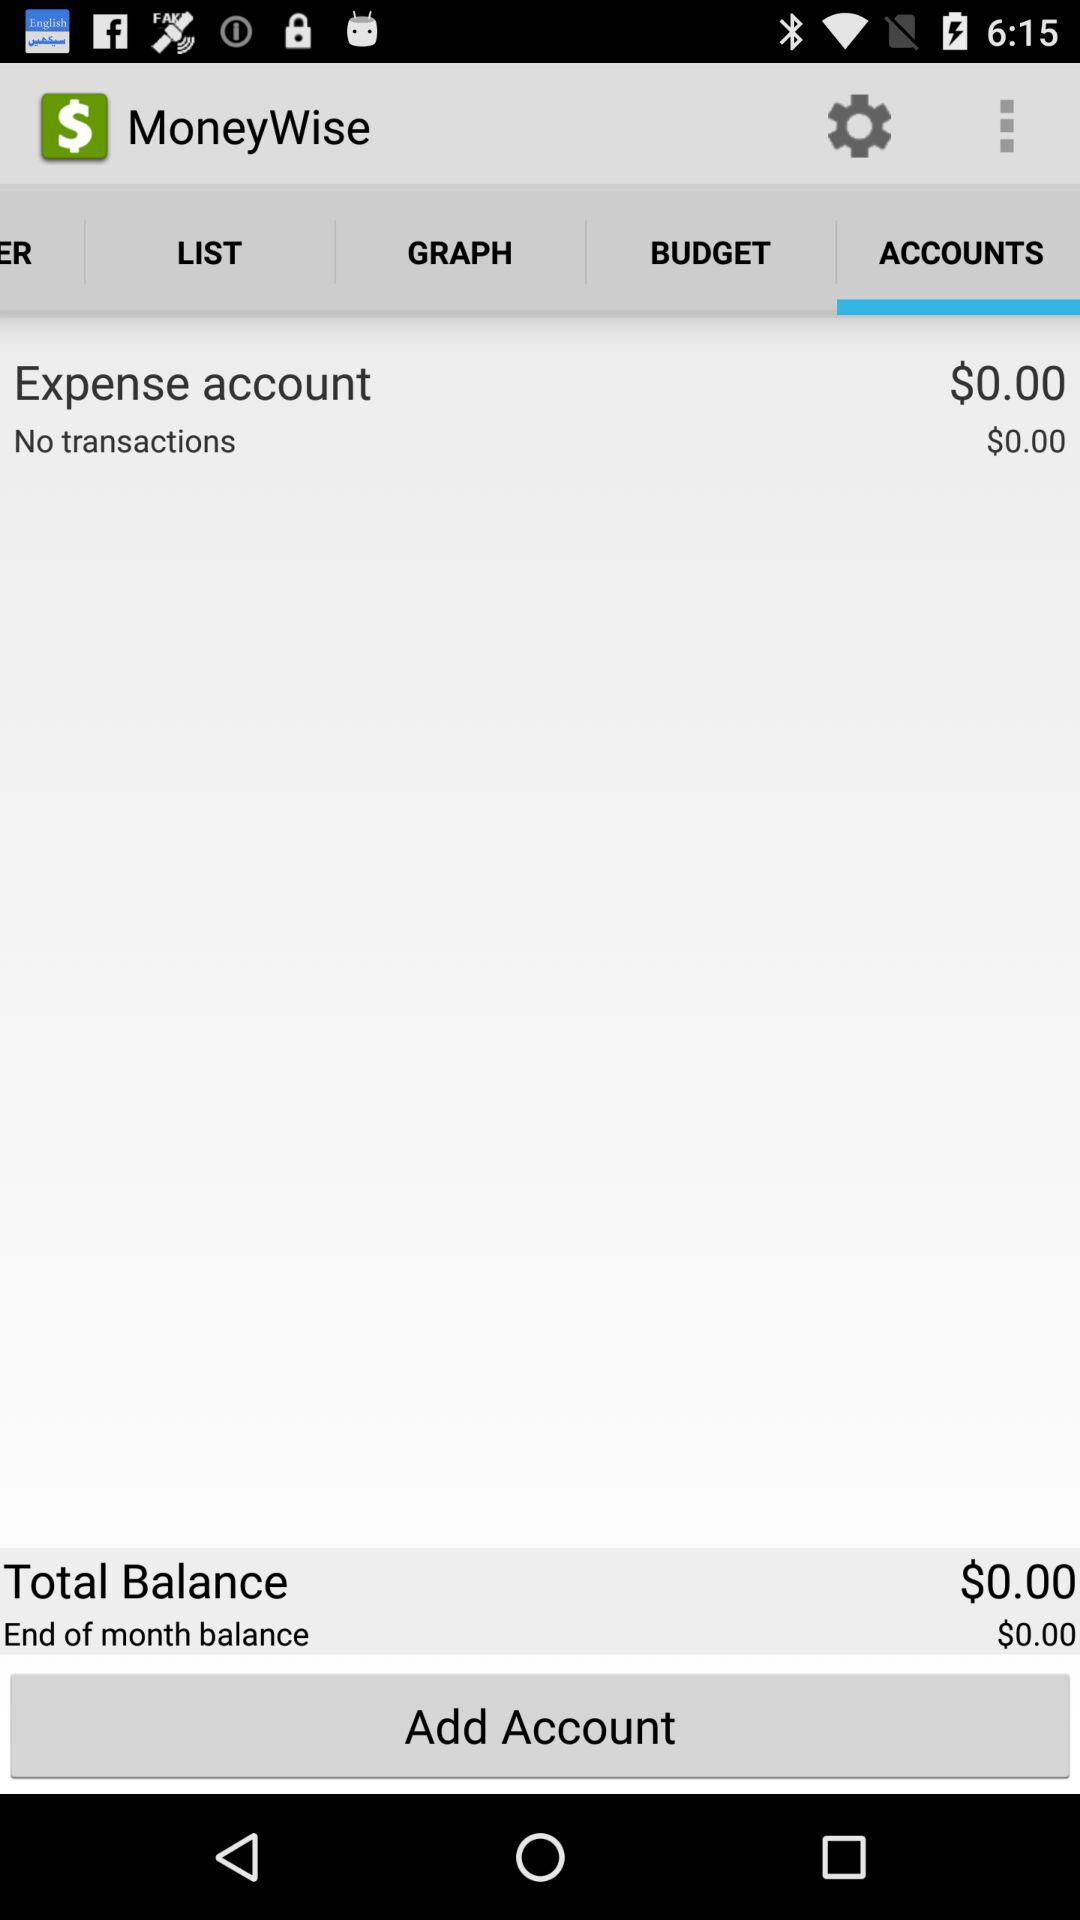How many transactions are there? There are no transactions. 